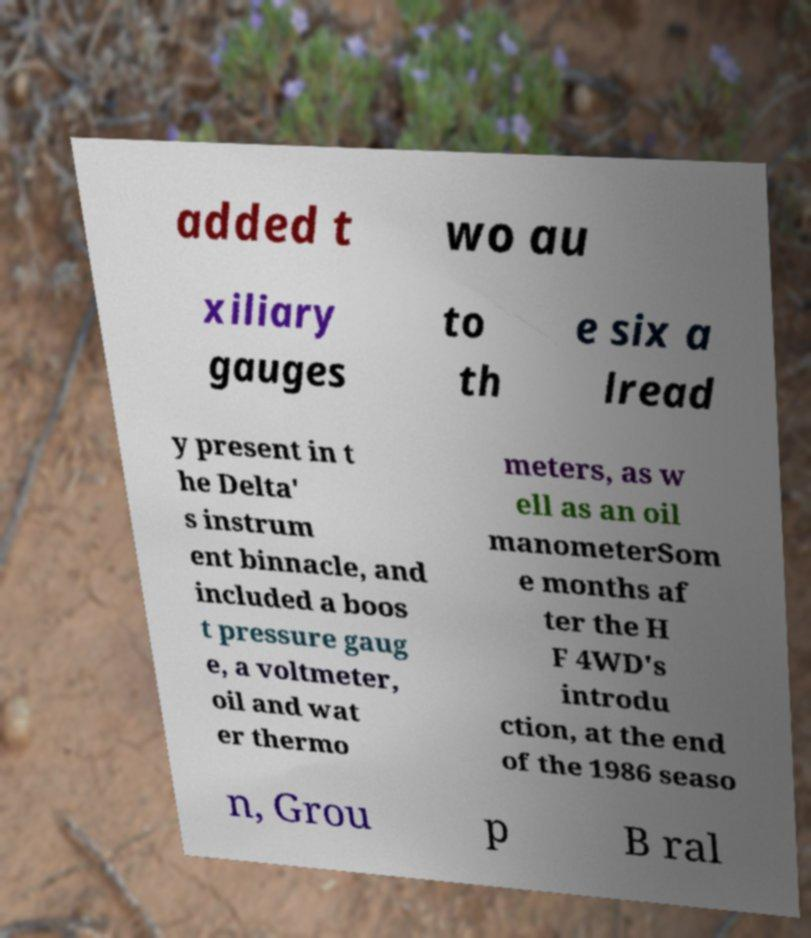What messages or text are displayed in this image? I need them in a readable, typed format. added t wo au xiliary gauges to th e six a lread y present in t he Delta' s instrum ent binnacle, and included a boos t pressure gaug e, a voltmeter, oil and wat er thermo meters, as w ell as an oil manometerSom e months af ter the H F 4WD's introdu ction, at the end of the 1986 seaso n, Grou p B ral 